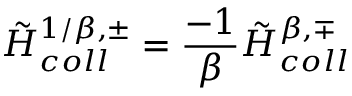Convert formula to latex. <formula><loc_0><loc_0><loc_500><loc_500>{ \tilde { H } } _ { c o l l } ^ { 1 / \beta , \pm } = { \frac { - 1 } { \beta } } { \tilde { H } } _ { c o l l } ^ { \beta , \mp }</formula> 